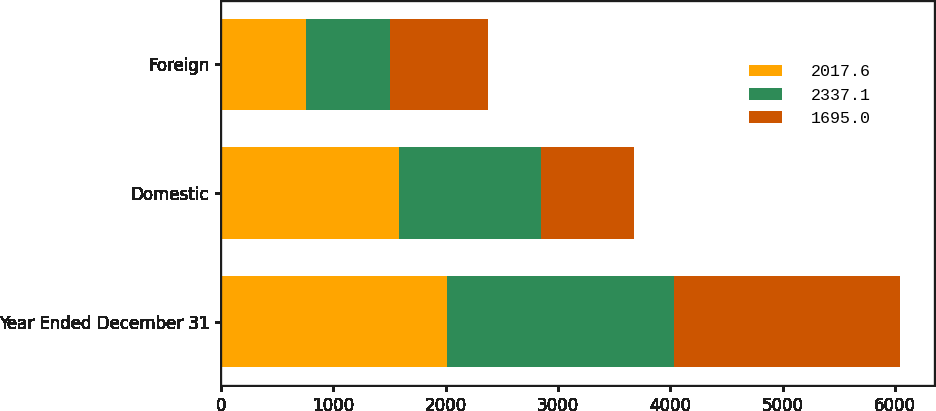Convert chart to OTSL. <chart><loc_0><loc_0><loc_500><loc_500><stacked_bar_chart><ecel><fcel>Year Ended December 31<fcel>Domestic<fcel>Foreign<nl><fcel>2017.6<fcel>2015<fcel>1581.6<fcel>755.5<nl><fcel>2337.1<fcel>2014<fcel>1267.3<fcel>750.3<nl><fcel>1695<fcel>2013<fcel>827<fcel>868<nl></chart> 